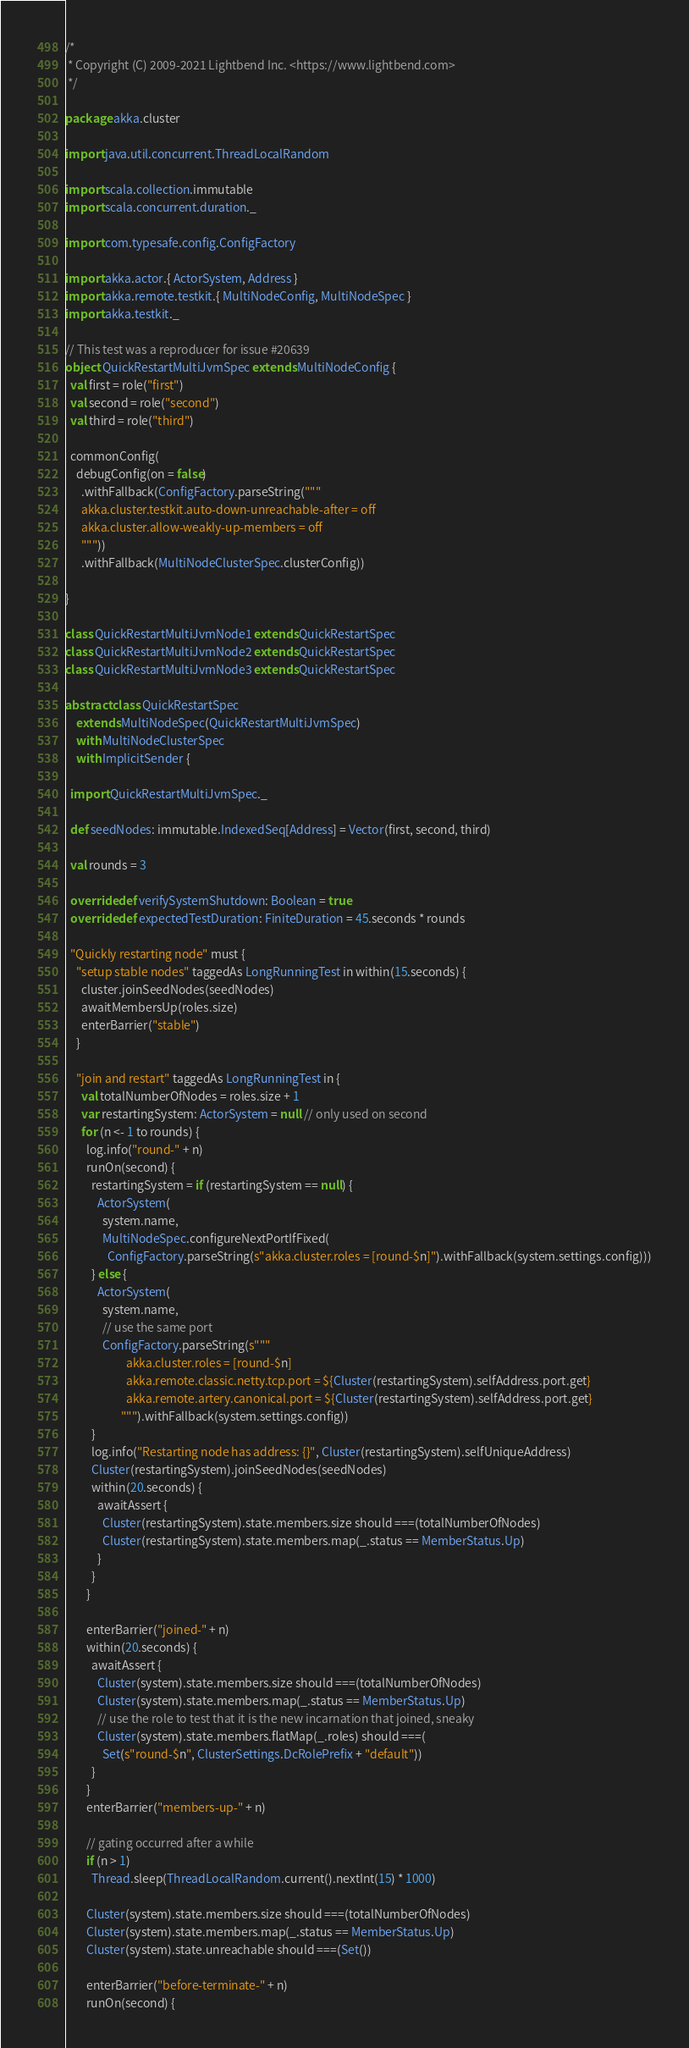Convert code to text. <code><loc_0><loc_0><loc_500><loc_500><_Scala_>/*
 * Copyright (C) 2009-2021 Lightbend Inc. <https://www.lightbend.com>
 */

package akka.cluster

import java.util.concurrent.ThreadLocalRandom

import scala.collection.immutable
import scala.concurrent.duration._

import com.typesafe.config.ConfigFactory

import akka.actor.{ ActorSystem, Address }
import akka.remote.testkit.{ MultiNodeConfig, MultiNodeSpec }
import akka.testkit._

// This test was a reproducer for issue #20639
object QuickRestartMultiJvmSpec extends MultiNodeConfig {
  val first = role("first")
  val second = role("second")
  val third = role("third")

  commonConfig(
    debugConfig(on = false)
      .withFallback(ConfigFactory.parseString("""
      akka.cluster.testkit.auto-down-unreachable-after = off
      akka.cluster.allow-weakly-up-members = off
      """))
      .withFallback(MultiNodeClusterSpec.clusterConfig))

}

class QuickRestartMultiJvmNode1 extends QuickRestartSpec
class QuickRestartMultiJvmNode2 extends QuickRestartSpec
class QuickRestartMultiJvmNode3 extends QuickRestartSpec

abstract class QuickRestartSpec
    extends MultiNodeSpec(QuickRestartMultiJvmSpec)
    with MultiNodeClusterSpec
    with ImplicitSender {

  import QuickRestartMultiJvmSpec._

  def seedNodes: immutable.IndexedSeq[Address] = Vector(first, second, third)

  val rounds = 3

  override def verifySystemShutdown: Boolean = true
  override def expectedTestDuration: FiniteDuration = 45.seconds * rounds

  "Quickly restarting node" must {
    "setup stable nodes" taggedAs LongRunningTest in within(15.seconds) {
      cluster.joinSeedNodes(seedNodes)
      awaitMembersUp(roles.size)
      enterBarrier("stable")
    }

    "join and restart" taggedAs LongRunningTest in {
      val totalNumberOfNodes = roles.size + 1
      var restartingSystem: ActorSystem = null // only used on second
      for (n <- 1 to rounds) {
        log.info("round-" + n)
        runOn(second) {
          restartingSystem = if (restartingSystem == null) {
            ActorSystem(
              system.name,
              MultiNodeSpec.configureNextPortIfFixed(
                ConfigFactory.parseString(s"akka.cluster.roles = [round-$n]").withFallback(system.settings.config)))
          } else {
            ActorSystem(
              system.name,
              // use the same port
              ConfigFactory.parseString(s"""
                       akka.cluster.roles = [round-$n]
                       akka.remote.classic.netty.tcp.port = ${Cluster(restartingSystem).selfAddress.port.get}
                       akka.remote.artery.canonical.port = ${Cluster(restartingSystem).selfAddress.port.get}
                     """).withFallback(system.settings.config))
          }
          log.info("Restarting node has address: {}", Cluster(restartingSystem).selfUniqueAddress)
          Cluster(restartingSystem).joinSeedNodes(seedNodes)
          within(20.seconds) {
            awaitAssert {
              Cluster(restartingSystem).state.members.size should ===(totalNumberOfNodes)
              Cluster(restartingSystem).state.members.map(_.status == MemberStatus.Up)
            }
          }
        }

        enterBarrier("joined-" + n)
        within(20.seconds) {
          awaitAssert {
            Cluster(system).state.members.size should ===(totalNumberOfNodes)
            Cluster(system).state.members.map(_.status == MemberStatus.Up)
            // use the role to test that it is the new incarnation that joined, sneaky
            Cluster(system).state.members.flatMap(_.roles) should ===(
              Set(s"round-$n", ClusterSettings.DcRolePrefix + "default"))
          }
        }
        enterBarrier("members-up-" + n)

        // gating occurred after a while
        if (n > 1)
          Thread.sleep(ThreadLocalRandom.current().nextInt(15) * 1000)

        Cluster(system).state.members.size should ===(totalNumberOfNodes)
        Cluster(system).state.members.map(_.status == MemberStatus.Up)
        Cluster(system).state.unreachable should ===(Set())

        enterBarrier("before-terminate-" + n)
        runOn(second) {</code> 